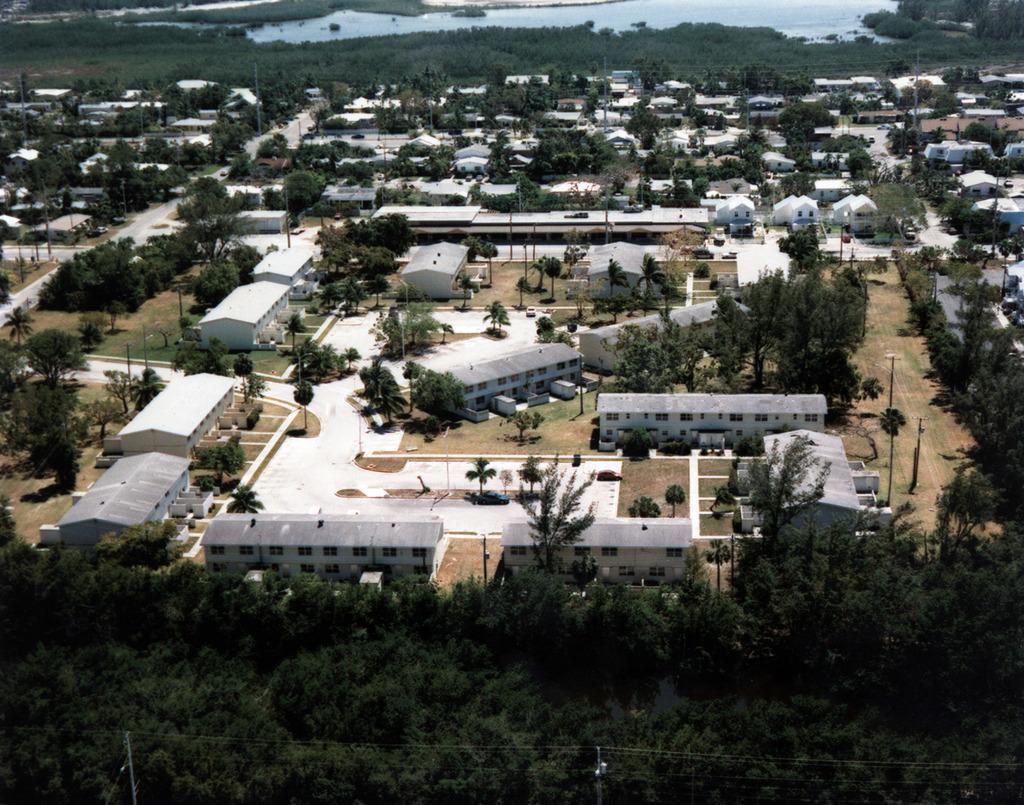Can you describe this image briefly? In this image I can see group of buildings and trees at the top I can see the lake at the bottom I can see power line cables and poles. 